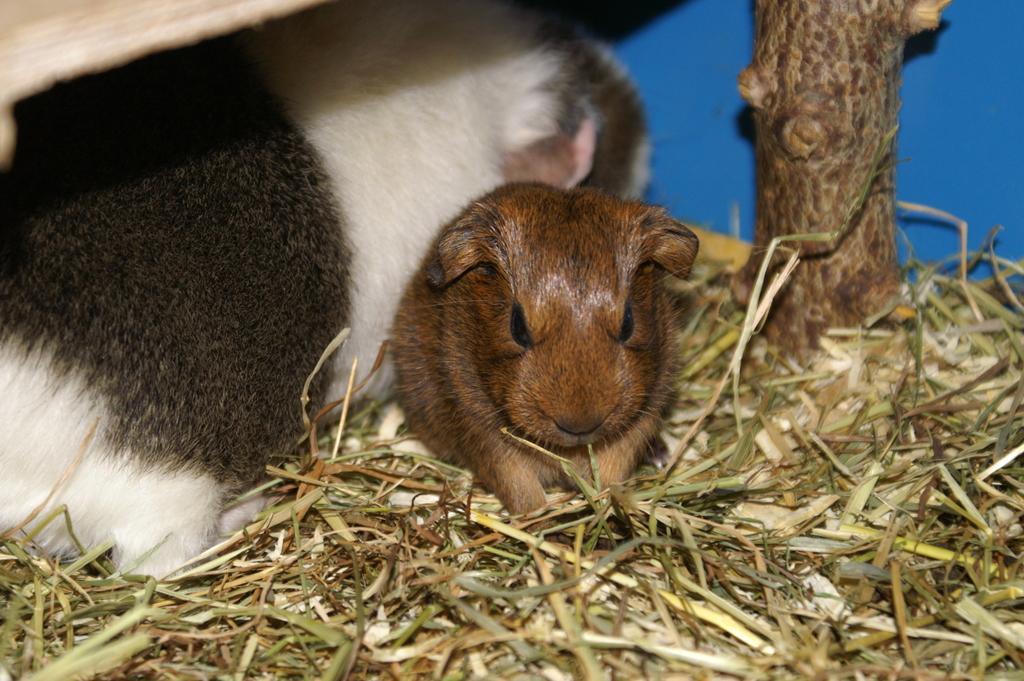In one or two sentences, can you explain what this image depicts? In this image we can see two animals on the dried grass. On the right we can see the bark of a tree. 